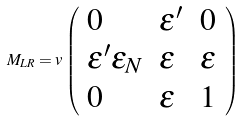<formula> <loc_0><loc_0><loc_500><loc_500>M _ { L R } = v \left ( \begin{array} { l l l } { 0 } & { { \epsilon ^ { \prime } } } & { 0 } \\ { { \epsilon ^ { \prime } \epsilon _ { N } } } & { \epsilon } & { \epsilon } \\ { 0 } & { \epsilon } & { 1 } \end{array} \right )</formula> 